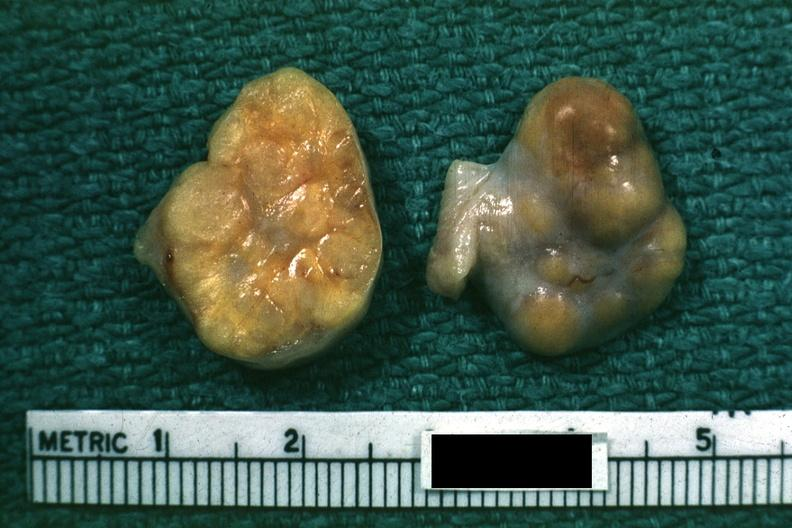what indicates theca cells can not recognize as ovary?
Answer the question using a single word or phrase. Yellow color 